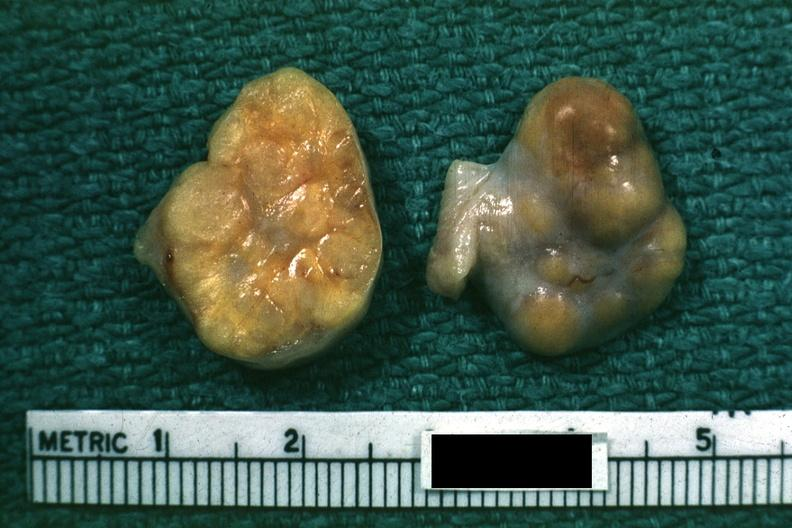what indicates theca cells can not recognize as ovary?
Answer the question using a single word or phrase. Yellow color 